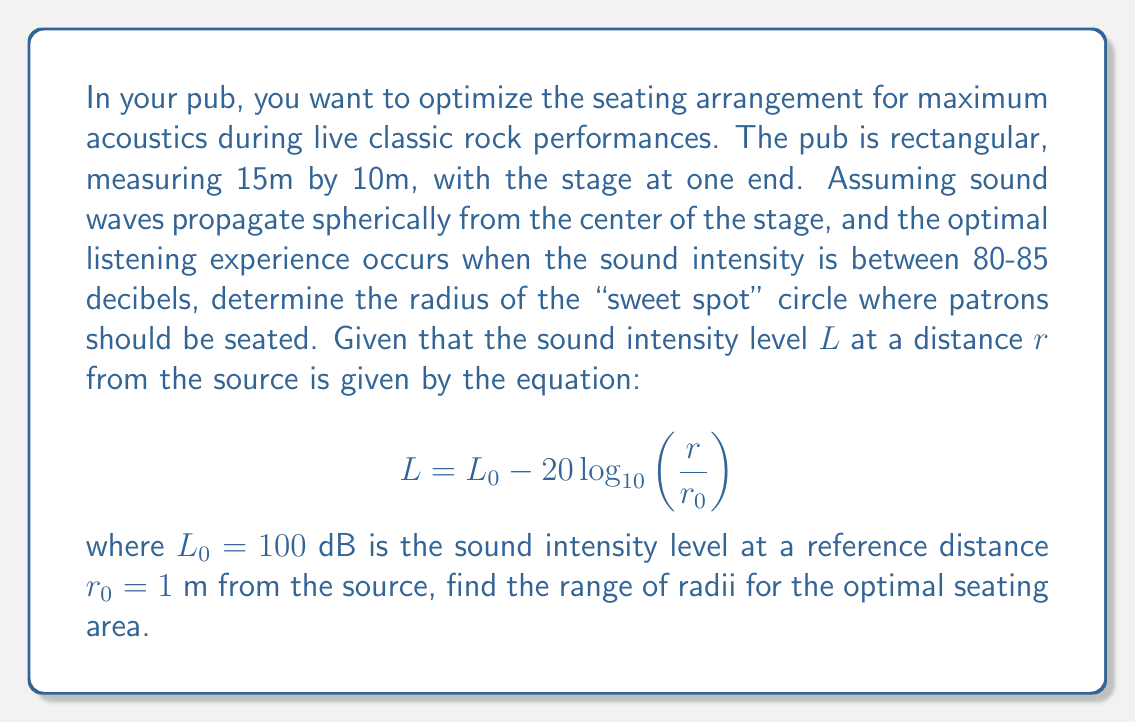Help me with this question. Let's approach this step-by-step:

1) We need to find the range of distances $r$ where the sound intensity level $L$ is between 80 and 85 dB.

2) We can use the given equation and solve it for $r$:

   $$L = 100 - 20 \log_{10}(r)$$

3) For the outer edge of the sweet spot (where $L = 80$ dB):

   $$80 = 100 - 20 \log_{10}(r_{max})$$
   $$20 = 20 \log_{10}(r_{max})$$
   $$\log_{10}(r_{max}) = 1$$
   $$r_{max} = 10^1 = 10\text{ m}$$

4) For the inner edge of the sweet spot (where $L = 85$ dB):

   $$85 = 100 - 20 \log_{10}(r_{min})$$
   $$15 = 20 \log_{10}(r_{min})$$
   $$\log_{10}(r_{min}) = 0.75$$
   $$r_{min} = 10^{0.75} \approx 5.62\text{ m}$$

5) Therefore, the optimal seating area is a circular ring with an inner radius of approximately 5.62 m and an outer radius of 10 m from the center of the stage.

6) This creates a "sweet spot" where classic rock enthusiasts can enjoy the best sound quality, reminiscent of the ideal listening experience at legendary venues like the Fillmore or CBGB.
Answer: The optimal seating area is a circular ring with radii between 5.62 m and 10 m from the stage center. 